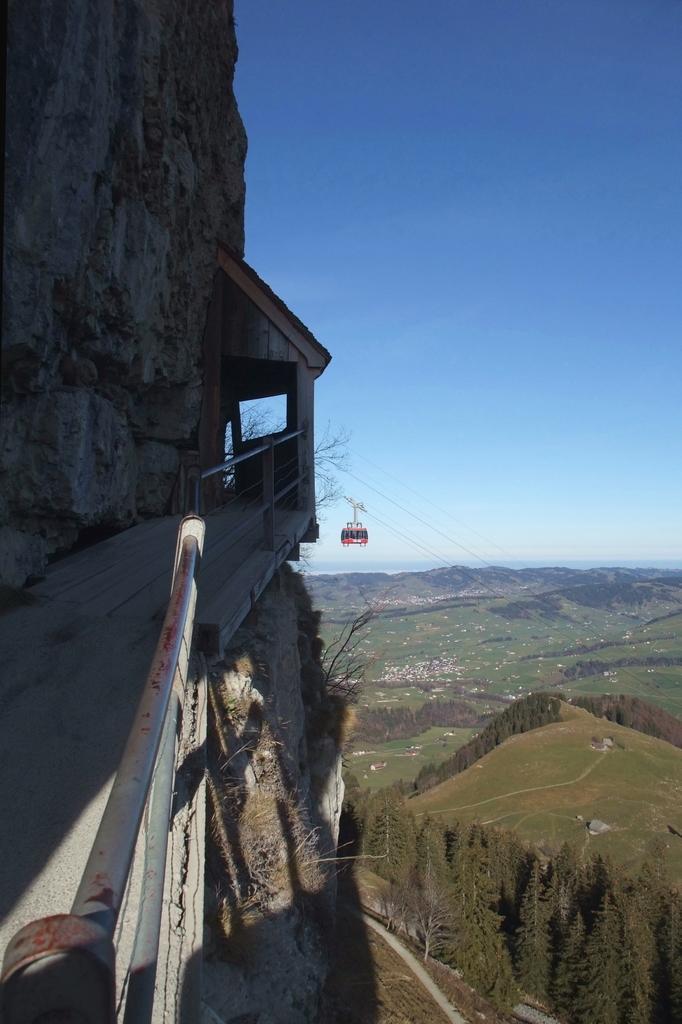Can you describe this image briefly? In this image I can see the sky and mountain and the hill 